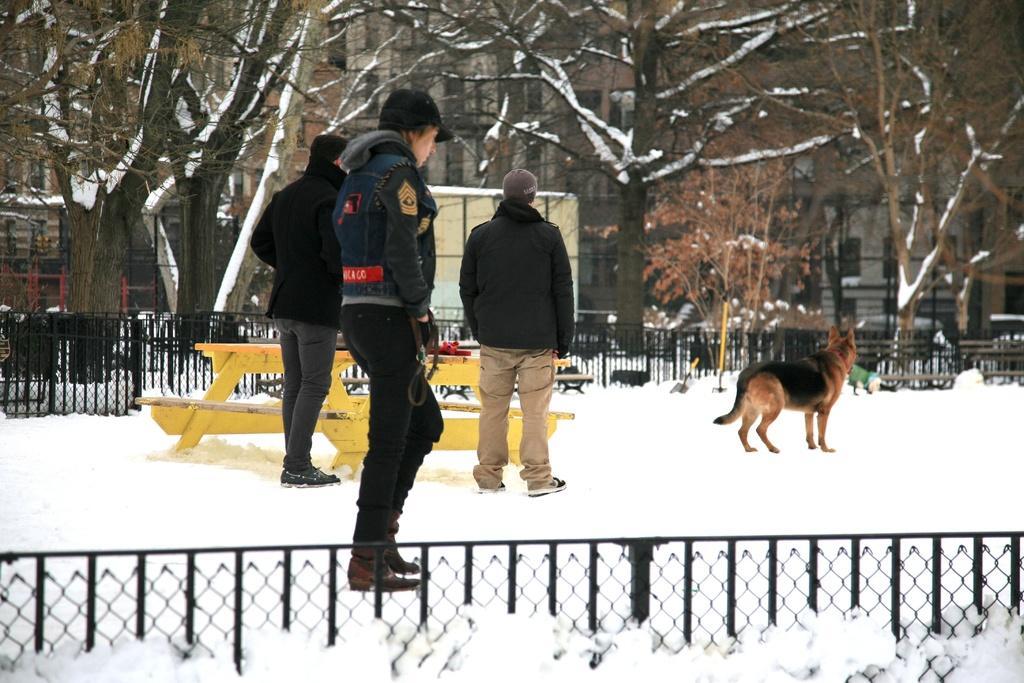Describe this image in one or two sentences. In this image, we can see two persons wearing clothes and standing on the snow. There is a bench and dog in the middle of the image. There is a fencing at the bottom of the image. In the background of the image, there are some trees. 